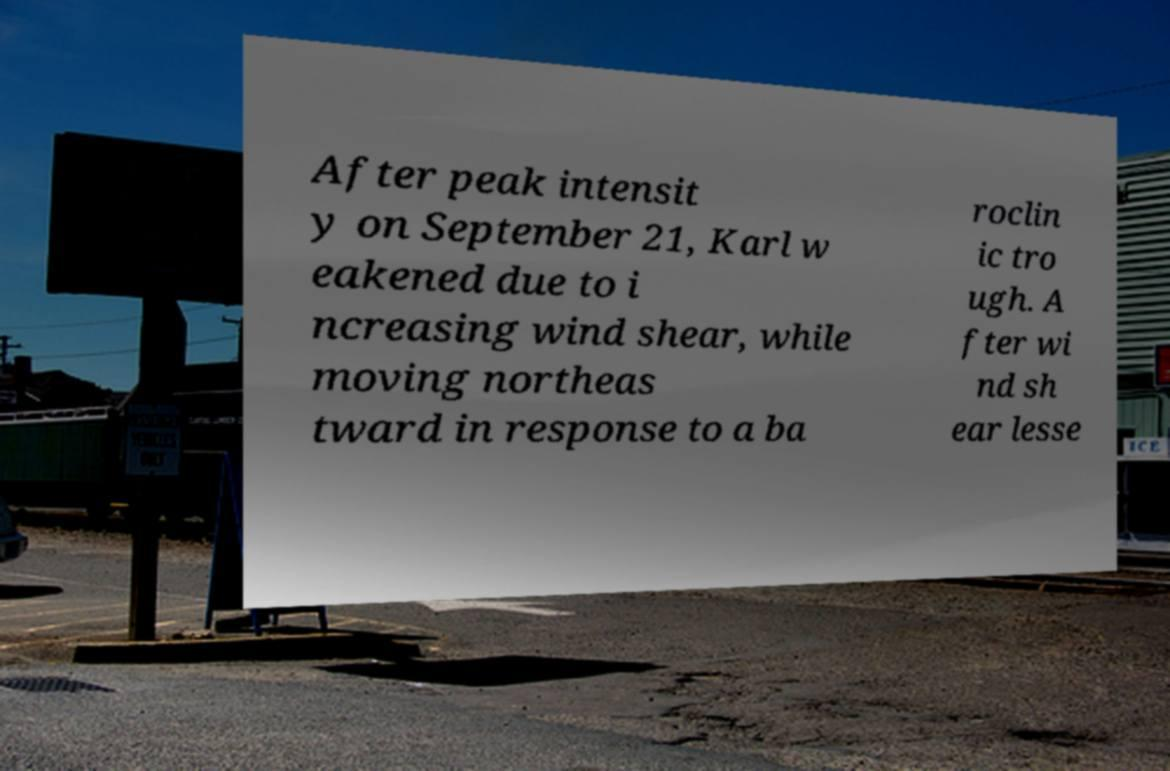Please read and relay the text visible in this image. What does it say? After peak intensit y on September 21, Karl w eakened due to i ncreasing wind shear, while moving northeas tward in response to a ba roclin ic tro ugh. A fter wi nd sh ear lesse 